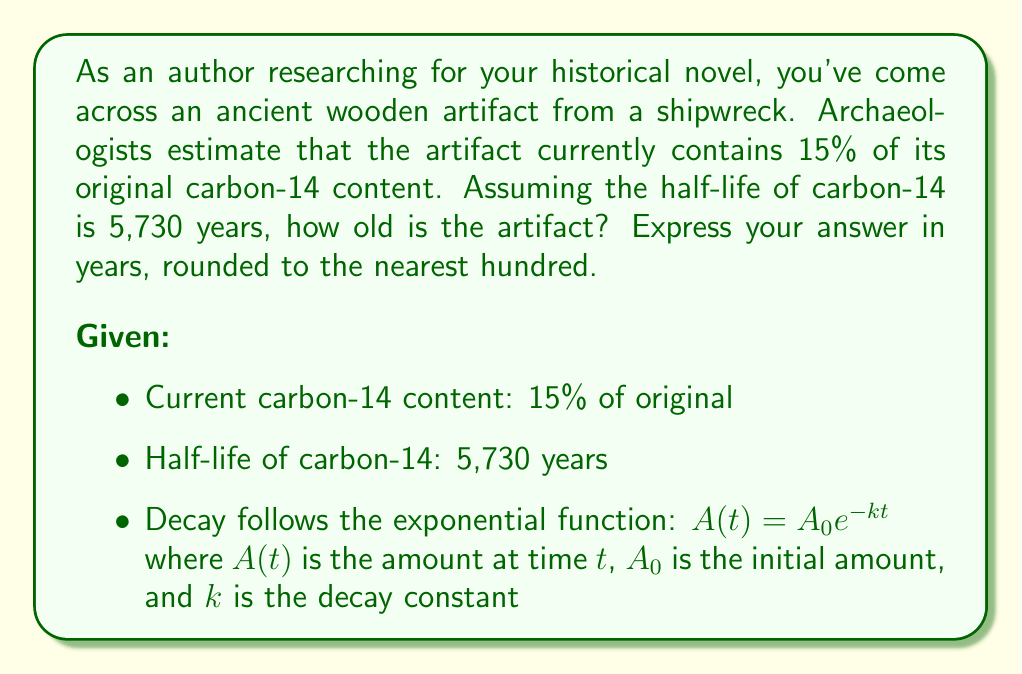Help me with this question. To solve this problem, we'll use the exponential decay function and the given information about carbon-14 decay. Let's approach this step-by-step:

1) The exponential decay function is:
   $A(t) = A_0 e^{-kt}$

2) We know that after time $t$, the remaining amount is 15% of the original. This means:
   $\frac{A(t)}{A_0} = 0.15$

3) Substituting this into our equation:
   $0.15 = e^{-kt}$

4) Taking the natural log of both sides:
   $\ln(0.15) = -kt$

5) Solve for $t$:
   $t = -\frac{\ln(0.15)}{k}$

6) Now we need to find $k$. We can use the half-life to do this. At the half-life ($t_{1/2}$), the amount remaining is half the original:
   $0.5 = e^{-k t_{1/2}}$

7) Taking the natural log and solving for $k$:
   $k = \frac{\ln(2)}{t_{1/2}} = \frac{\ln(2)}{5730} \approx 0.000121$

8) Now we can substitute this back into our equation for $t$:
   $t = -\frac{\ln(0.15)}{0.000121}$

9) Calculating this:
   $t \approx 15640.95$ years

10) Rounding to the nearest hundred years:
    $t \approx 15,600$ years
Answer: The artifact is approximately 15,600 years old. 